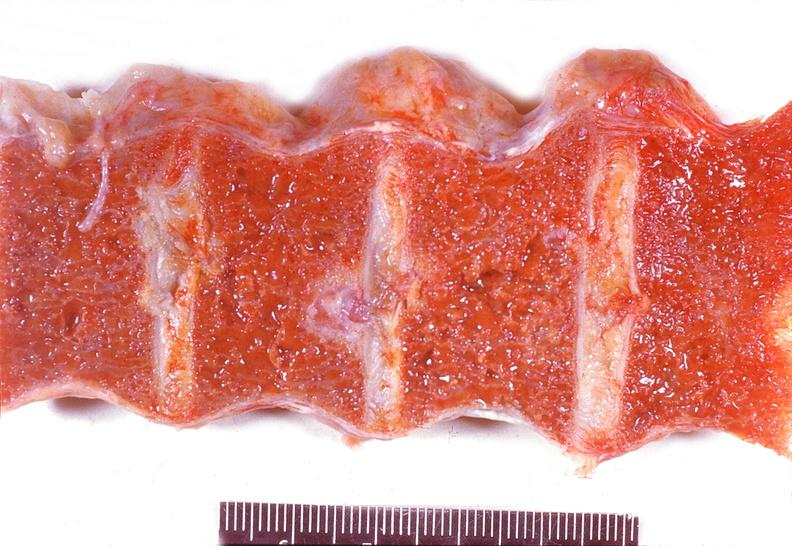s joints present?
Answer the question using a single word or phrase. Yes 